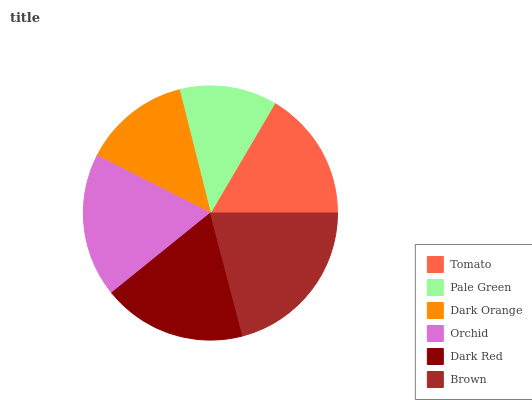Is Pale Green the minimum?
Answer yes or no. Yes. Is Brown the maximum?
Answer yes or no. Yes. Is Dark Orange the minimum?
Answer yes or no. No. Is Dark Orange the maximum?
Answer yes or no. No. Is Dark Orange greater than Pale Green?
Answer yes or no. Yes. Is Pale Green less than Dark Orange?
Answer yes or no. Yes. Is Pale Green greater than Dark Orange?
Answer yes or no. No. Is Dark Orange less than Pale Green?
Answer yes or no. No. Is Orchid the high median?
Answer yes or no. Yes. Is Tomato the low median?
Answer yes or no. Yes. Is Dark Red the high median?
Answer yes or no. No. Is Brown the low median?
Answer yes or no. No. 